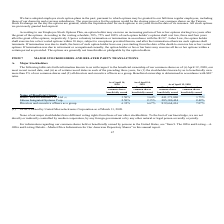According to United Micro Electronics's financial document, How is the Beneficial ownership determined? Beneficial ownership is determined in accordance with SEC rules.. The document states: ") all directors and executive officers as a group. Beneficial ownership is determined in accordance with SEC rules...." Also, Do the major stockholders have different voting rights? None of our major stockholders have different voting rights from those of our other stockholders.. The document states: "None of our major stockholders have different voting rights from those of our other stockholders. To the best of our knowledge, we are not directly or..." Also, Is the corporation regulated by second or third party regulator? we are not directly or indirectly controlled by another corporation, by any foreign government or by any other natural or legal person severally or jointly.. The document states: "other stockholders. To the best of our knowledge, we are not directly or indirectly controlled by another corporation, by any foreign government or by..." Also, can you calculate: What is the increase/ (decrease) in number of common shares beneficially owned of Silicon Integrated Systems Corp. from April 14, 2018 to April 14, 2019? Based on the calculation: 2.35-2.50, the result is -0.15 (percentage). This is based on the information: "41,371,000 3.75% Silicon Integrated Systems Corp. 2.50% 2.35% 285,380,424 2.42% Directors and executive officers as a group 6.32% 6.67% 832,664,416 7.07% ,000 3.75% Silicon Integrated Systems Corp. 2...." The key data points involved are: 2.35, 2.50. Also, can you calculate: What is the increase/ (decrease) in number of common shares beneficially owned of Hsun Chieh Investment Co., Ltd. from April 14, 2018 to April 14, 2019? Based on the calculation: 3.64-3.50, the result is 0.14 (percentage). This is based on the information: "l Owner Hsun Chieh Investment Co., Ltd. (1) 3.50% 3.64% 441,371,000 3.75% Silicon Integrated Systems Corp. 2.50% 2.35% 285,380,424 2.42% Directors and exe eficial Owner Hsun Chieh Investment Co., Ltd...." The key data points involved are: 3.50, 3.64. Also, can you calculate: What is the increase/ (decrease) in number of common shares beneficially owned of Directors and executive officers as a group from April 14, 2018 to April 14, 2019? Based on the calculation: 6.67-6.32, the result is 0.35 (percentage). This is based on the information: "2.42% Directors and executive officers as a group 6.32% 6.67% 832,664,416 7.07% Directors and executive officers as a group 6.32% 6.67% 832,664,416 7.07%..." The key data points involved are: 6.32, 6.67. 